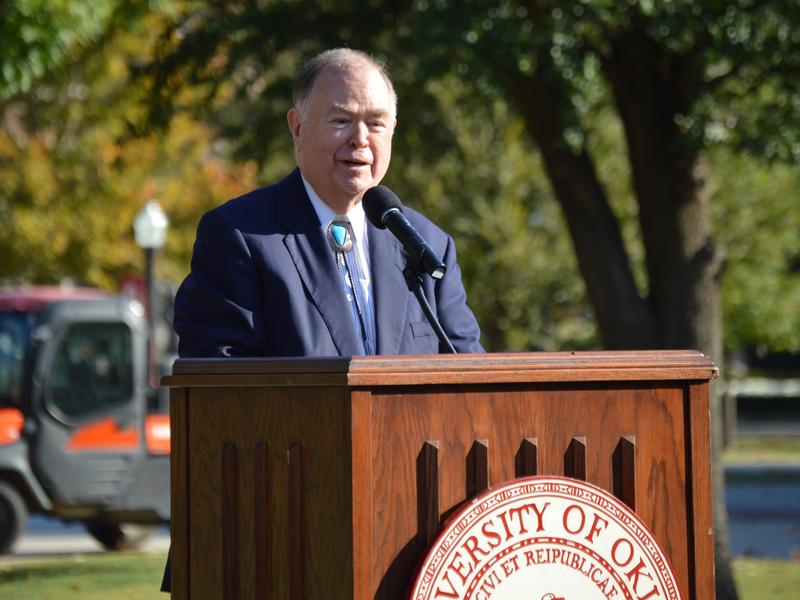What could be the significance of the seal on the podium where the man is speaking? The seal on the podium represents the University of Oklahoma, which suggests that the event is a significant academic or administrative function hosted by the university. Such seals are typically used in formal settings, symbolizing the university's endorsement and authority. The event could range from a formal inauguration, a significant academic lecture, a celebratory event, or a major announcement affecting the university community. The presence of the seal underscores the official nature of the gathering and aligns it with the university's traditions and values. 